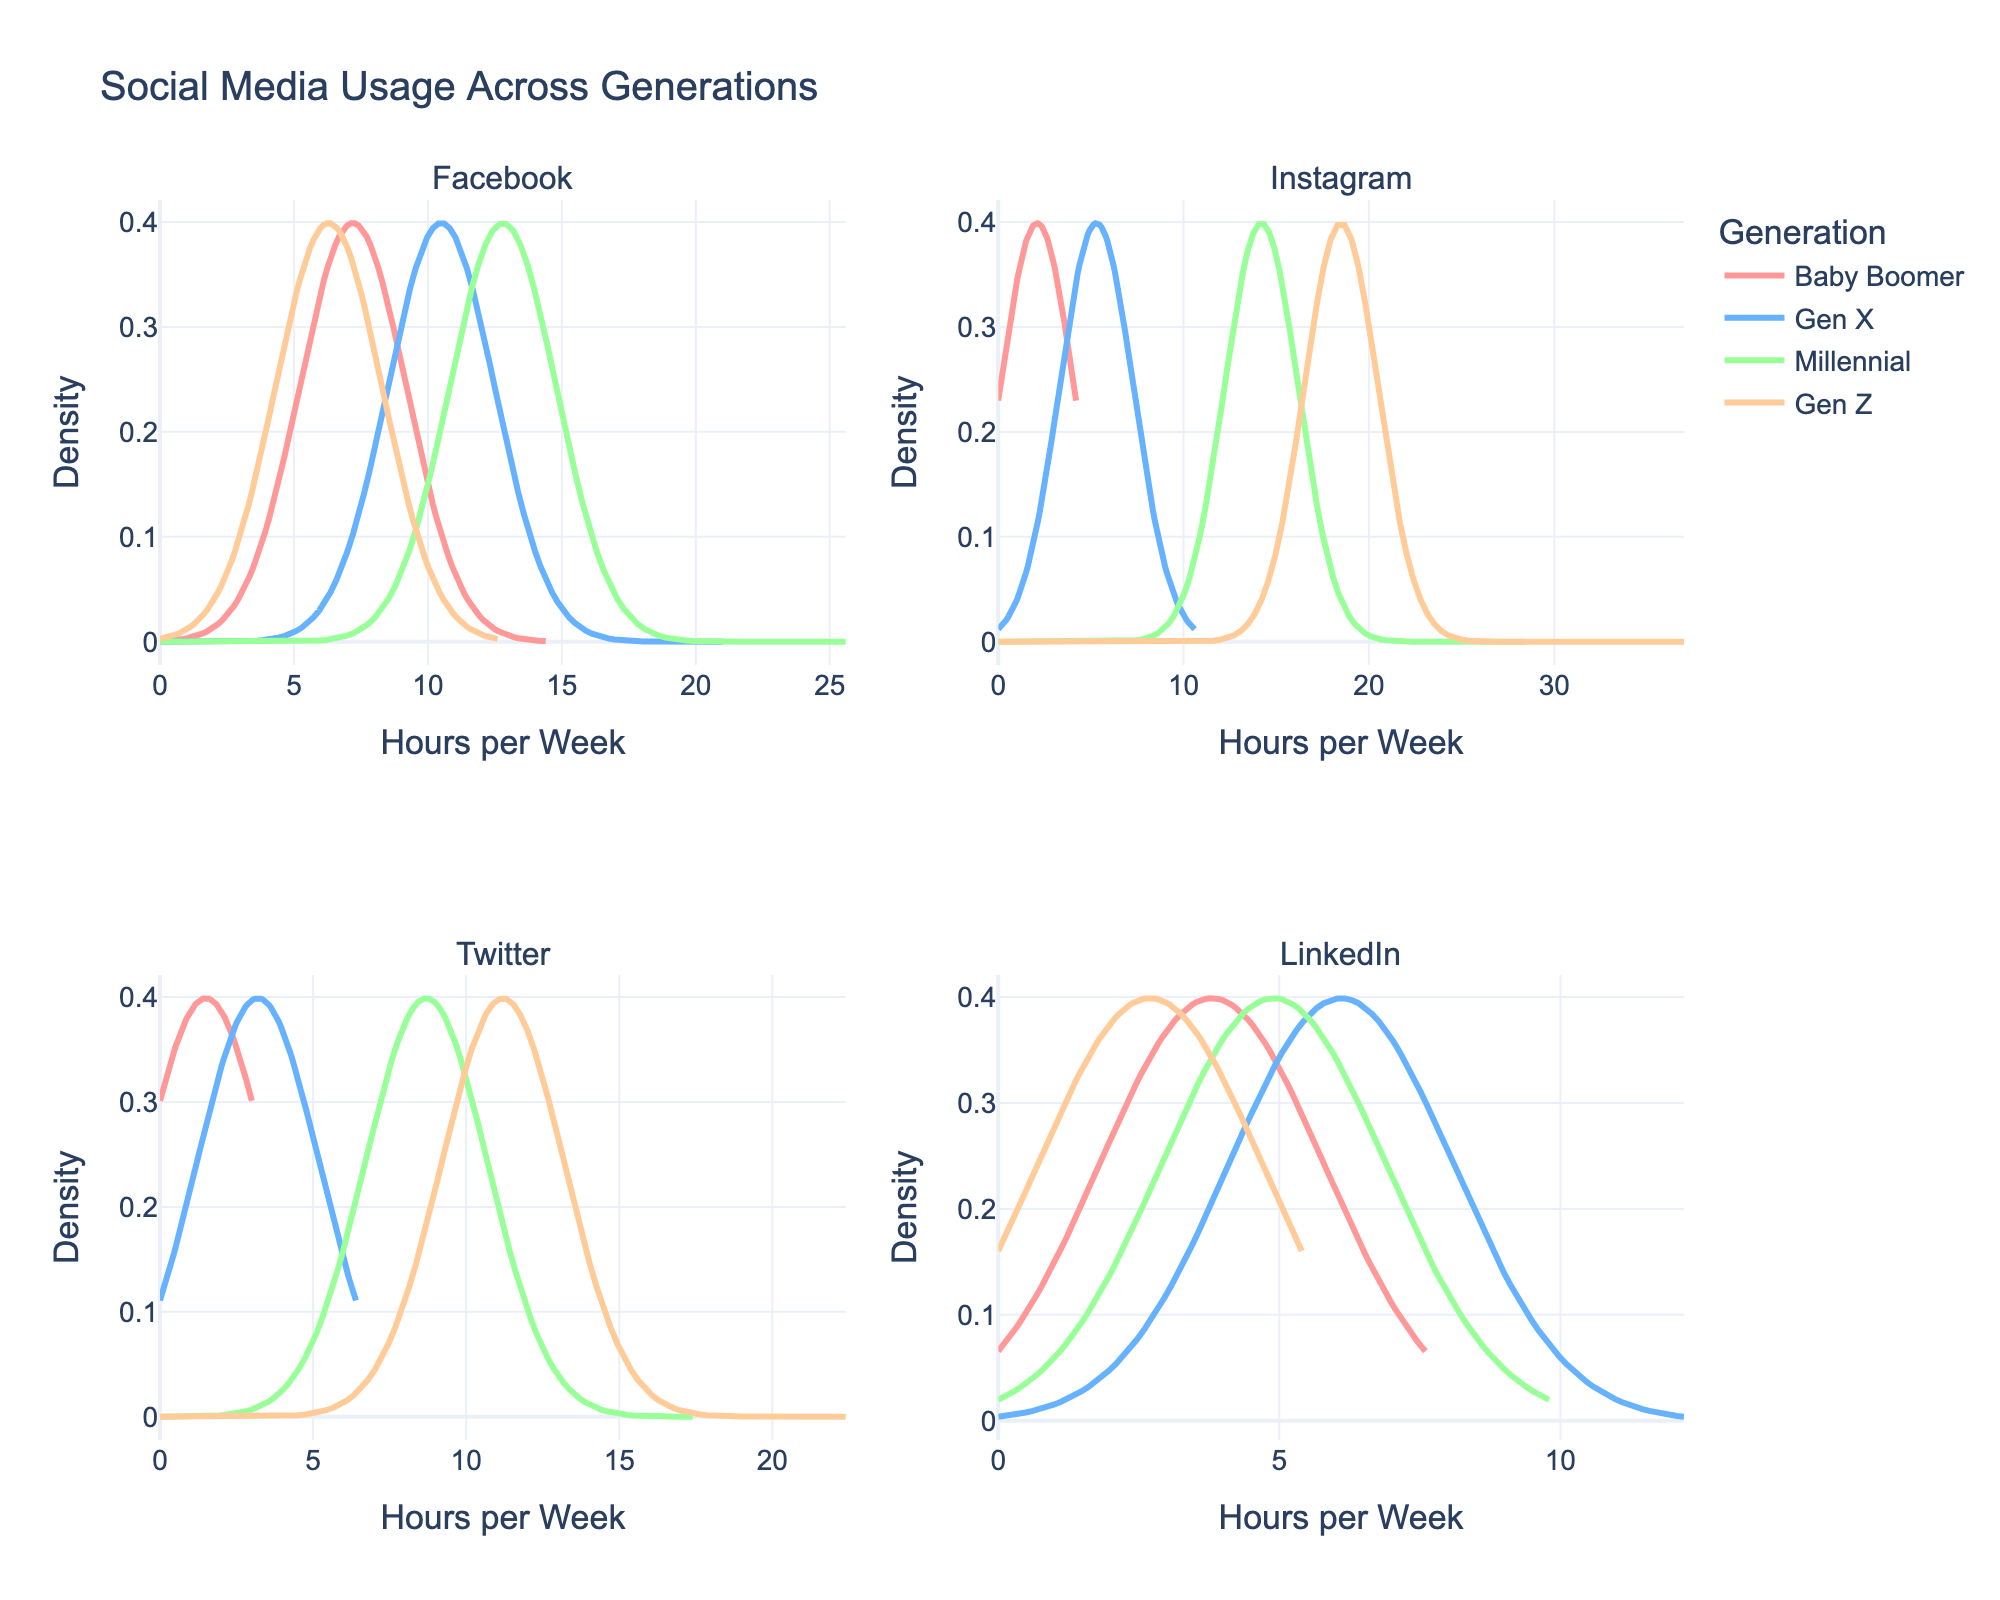what is the title of the figure? The title is usually located at the top of the figure, clearly stating what the figure represents.
Answer: Social Media Usage Across Generations How many subplots are there in the figure? The figure is divided into smaller sections, or subplots, each representing different platforms.
Answer: 4 Which generation has the highest peak for Instagram usage? Look for the subplot titled "Instagram" and observe which line reaches the highest peak on the y-axis.
Answer: Gen Z In the LinkedIn subplot, which generation has the widest spread of usage hours? For the subplot titled "LinkedIn", observe which line extends the furthest on the x-axis.
Answer: Gen X Which platform do Millennials use the most? Check the subplot for each platform and compare the heights of the lines representing Millennials.
Answer: Instagram Comparing Gen X across all subplots, for which platform do they have the lowest peak in usage hours? Look at the lines for Gen X in each subplot and identify where they have the smallest peak.
Answer: Twitter How does Gen Z's usage of Twitter compare to Gen X's usage of Facebook? Compare the height and spread of the peaks for Gen Z in the "Twitter" subplot to Gen X in the "Facebook" subplot.
Answer: Gen Z's Twitter usage is higher and more spread out than Gen X's Facebook usage What is the color representing Baby Boomers in the figure? Find the color key or legend in the figure and note the color associated with Baby Boomers.
Answer: Red In which subplot does the Millennial generation have the smallest peak? Look at the peaks of the Millennial lines in each subplot and identify the smallest one.
Answer: LinkedIn 